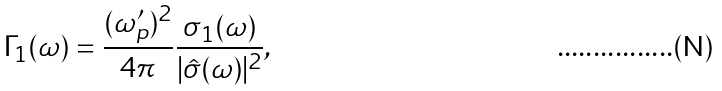Convert formula to latex. <formula><loc_0><loc_0><loc_500><loc_500>\Gamma _ { 1 } ( \omega ) = \frac { ( \omega _ { p } ^ { \prime } ) ^ { 2 } } { 4 \pi } \frac { \sigma _ { 1 } ( \omega ) } { | \hat { \sigma } ( \omega ) | ^ { 2 } } ,</formula> 